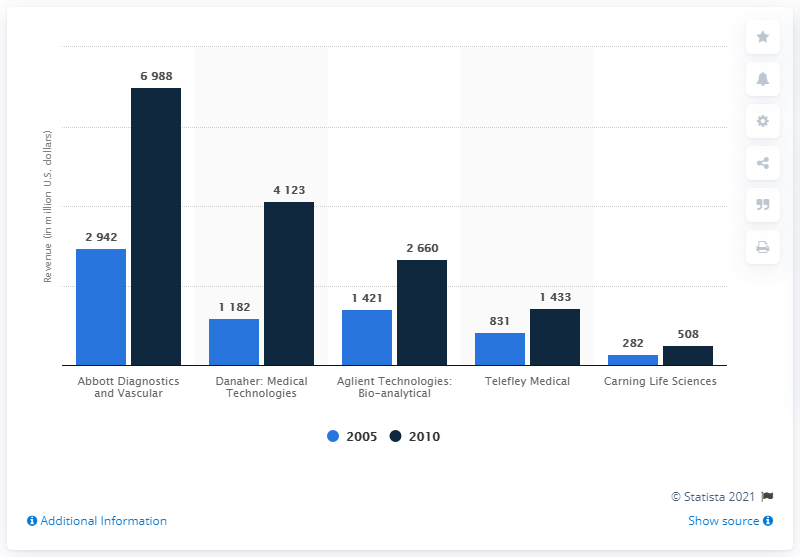Mention a couple of crucial points in this snapshot. In 2005, Teleflex Medical generated approximately $831 million in revenue. 